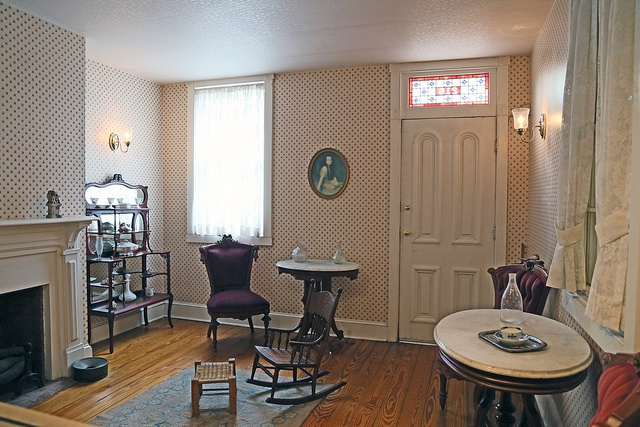Describe the objects in this image and their specific colors. I can see chair in gray, black, and darkgray tones, chair in gray, black, and purple tones, chair in gray, black, and purple tones, bottle in gray and darkgray tones, and bowl in gray, darkgray, lightblue, and black tones in this image. 